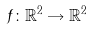<formula> <loc_0><loc_0><loc_500><loc_500>f \colon \mathbb { R } ^ { 2 } \rightarrow \mathbb { R } ^ { 2 }</formula> 